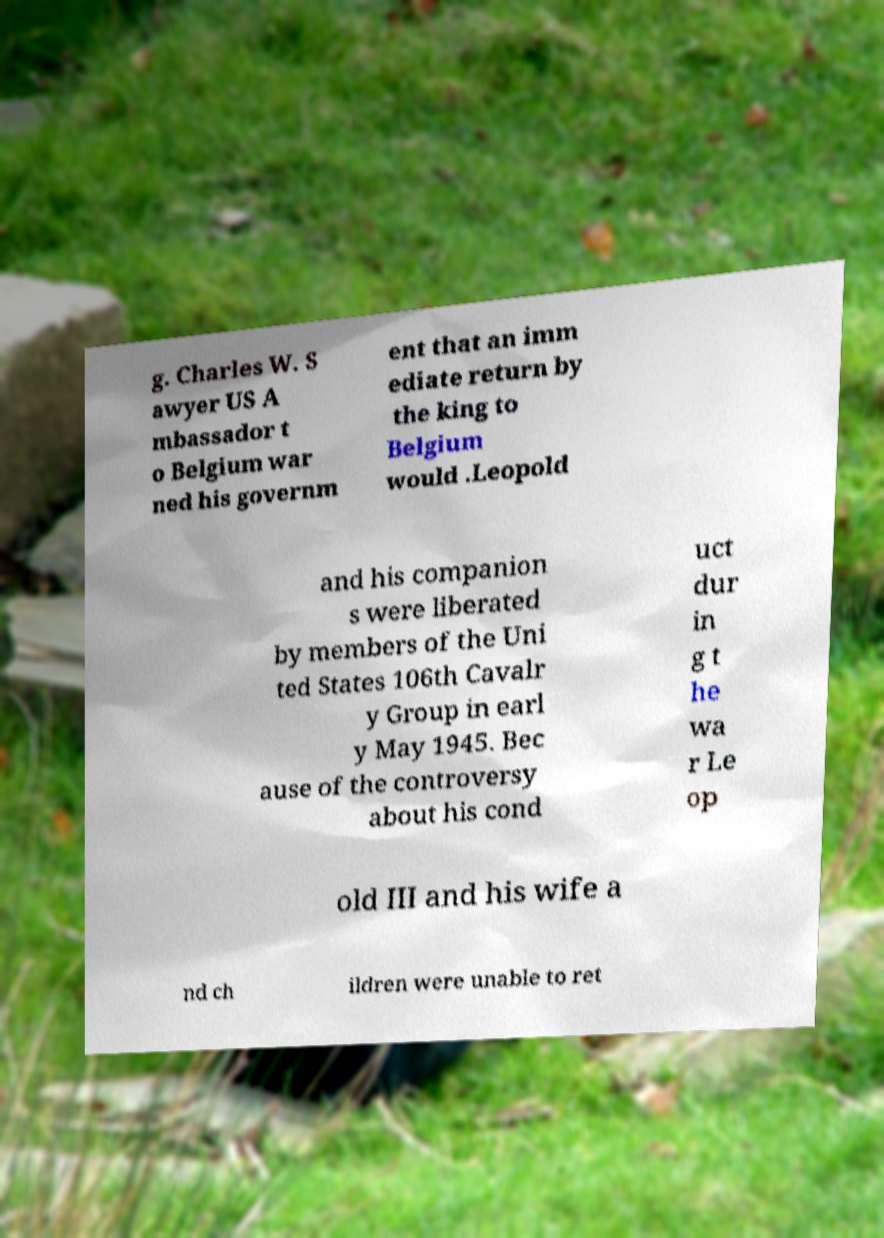Could you extract and type out the text from this image? g. Charles W. S awyer US A mbassador t o Belgium war ned his governm ent that an imm ediate return by the king to Belgium would .Leopold and his companion s were liberated by members of the Uni ted States 106th Cavalr y Group in earl y May 1945. Bec ause of the controversy about his cond uct dur in g t he wa r Le op old III and his wife a nd ch ildren were unable to ret 